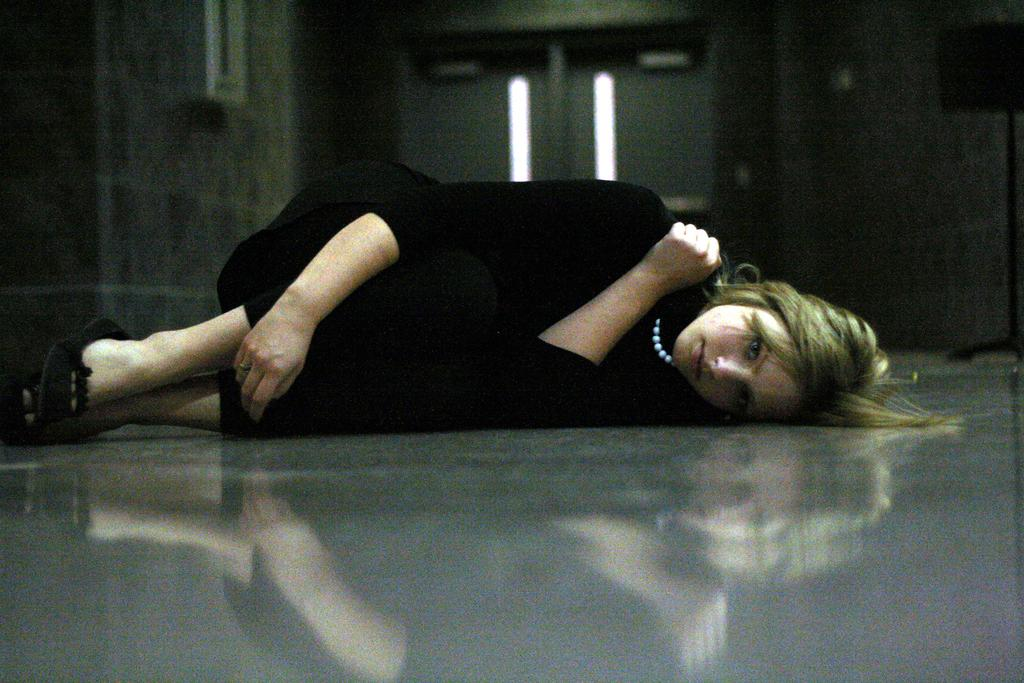Who is present in the image? There is a woman in the image. What is the woman wearing around her neck? The woman is wearing a locket. What color is the dress the woman is wearing? The woman is wearing a black dress. What is the woman's position in the image? The woman is lying on the floor. What architectural features can be seen in the background of the image? There is a door visible in the background of the image, and there is also a window on the wall in the image. How many planes can be seen flying outside the window in the image? There are no planes visible outside the window in the image. What type of toothbrush is the woman using in the image? There is no toothbrush present in the image. 